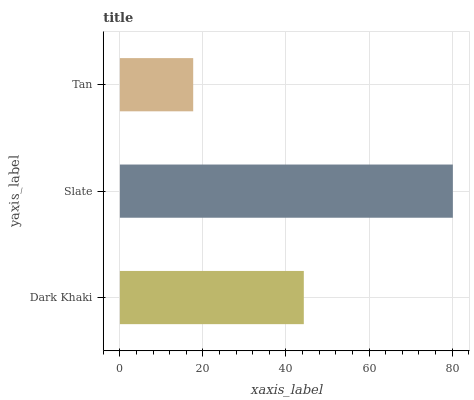Is Tan the minimum?
Answer yes or no. Yes. Is Slate the maximum?
Answer yes or no. Yes. Is Slate the minimum?
Answer yes or no. No. Is Tan the maximum?
Answer yes or no. No. Is Slate greater than Tan?
Answer yes or no. Yes. Is Tan less than Slate?
Answer yes or no. Yes. Is Tan greater than Slate?
Answer yes or no. No. Is Slate less than Tan?
Answer yes or no. No. Is Dark Khaki the high median?
Answer yes or no. Yes. Is Dark Khaki the low median?
Answer yes or no. Yes. Is Tan the high median?
Answer yes or no. No. Is Slate the low median?
Answer yes or no. No. 